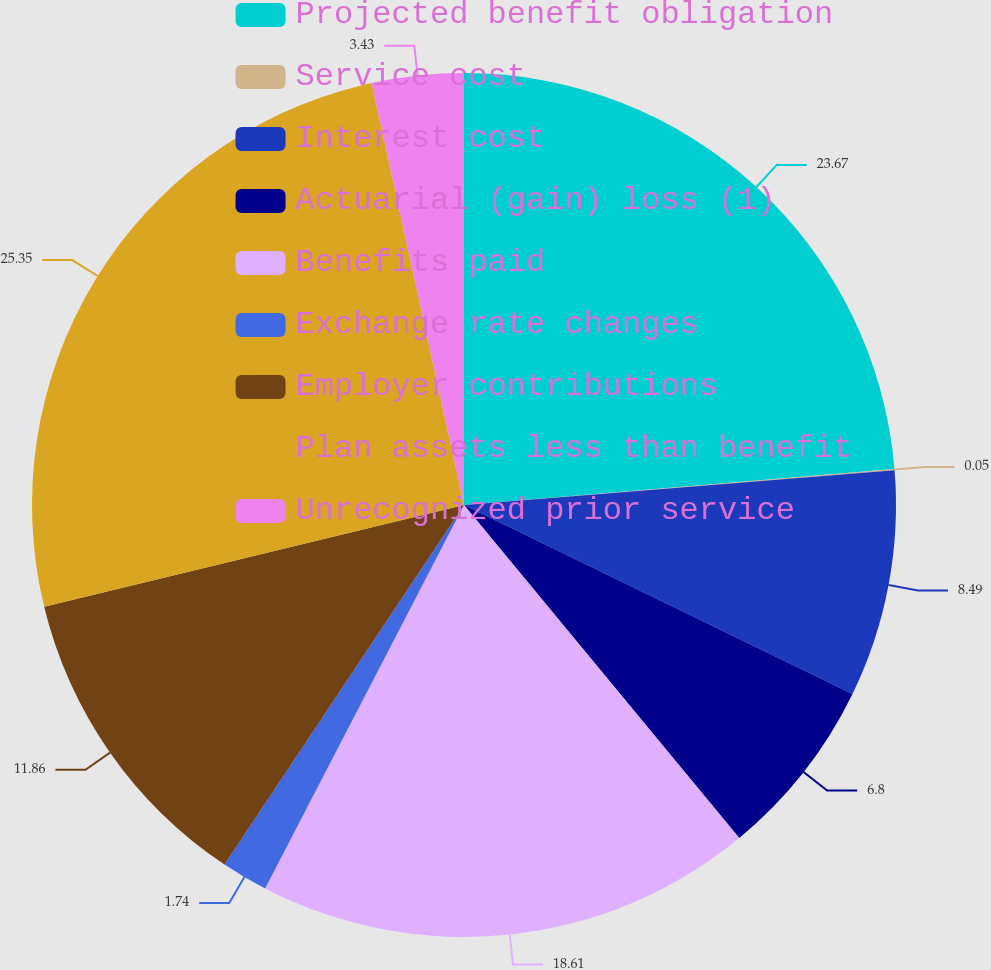<chart> <loc_0><loc_0><loc_500><loc_500><pie_chart><fcel>Projected benefit obligation<fcel>Service cost<fcel>Interest cost<fcel>Actuarial (gain) loss (1)<fcel>Benefits paid<fcel>Exchange rate changes<fcel>Employer contributions<fcel>Plan assets less than benefit<fcel>Unrecognized prior service<nl><fcel>23.67%<fcel>0.05%<fcel>8.49%<fcel>6.8%<fcel>18.61%<fcel>1.74%<fcel>11.86%<fcel>25.36%<fcel>3.43%<nl></chart> 